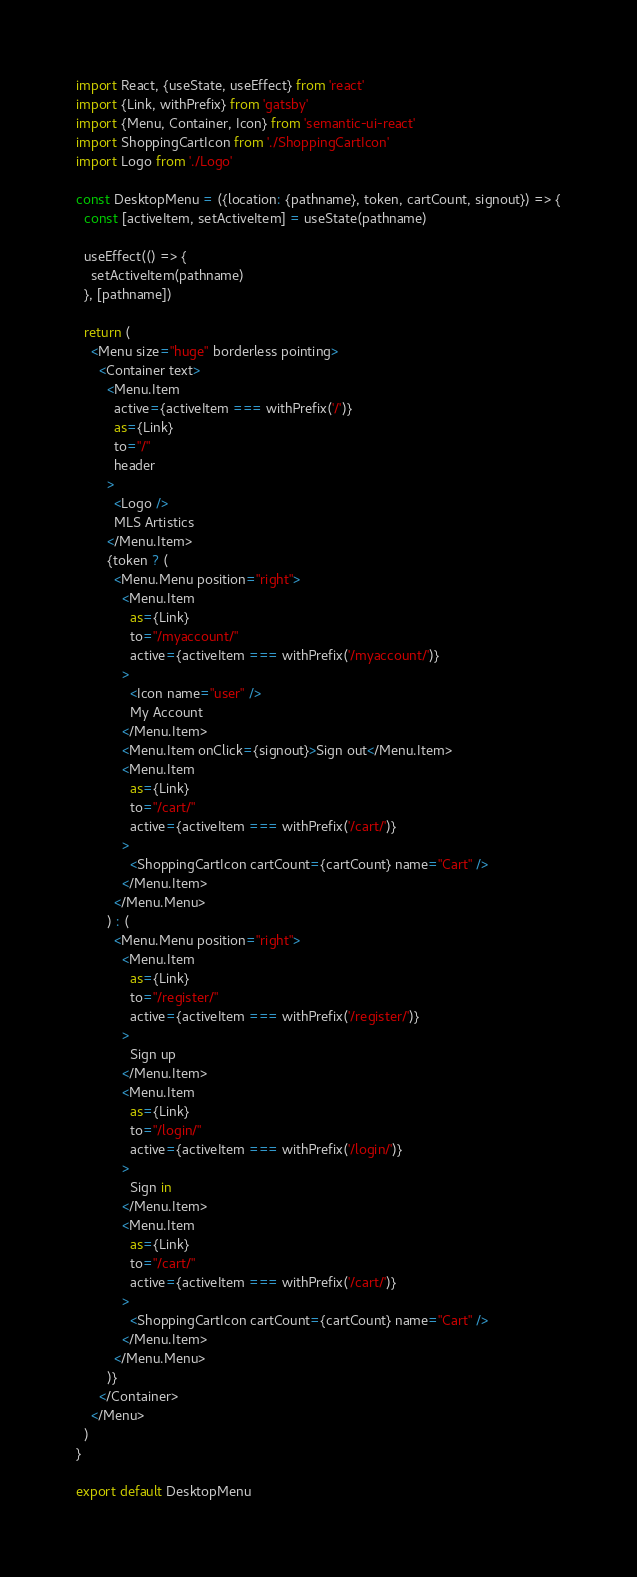<code> <loc_0><loc_0><loc_500><loc_500><_JavaScript_>import React, {useState, useEffect} from 'react'
import {Link, withPrefix} from 'gatsby'
import {Menu, Container, Icon} from 'semantic-ui-react'
import ShoppingCartIcon from './ShoppingCartIcon'
import Logo from './Logo'

const DesktopMenu = ({location: {pathname}, token, cartCount, signout}) => {
  const [activeItem, setActiveItem] = useState(pathname)

  useEffect(() => {
    setActiveItem(pathname)
  }, [pathname])

  return (
    <Menu size="huge" borderless pointing>
      <Container text>
        <Menu.Item
          active={activeItem === withPrefix('/')}
          as={Link}
          to="/"
          header
        >
          <Logo />
          MLS Artistics
        </Menu.Item>
        {token ? (
          <Menu.Menu position="right">
            <Menu.Item
              as={Link}
              to="/myaccount/"
              active={activeItem === withPrefix('/myaccount/')}
            >
              <Icon name="user" />
              My Account
            </Menu.Item>
            <Menu.Item onClick={signout}>Sign out</Menu.Item>
            <Menu.Item
              as={Link}
              to="/cart/"
              active={activeItem === withPrefix('/cart/')}
            >
              <ShoppingCartIcon cartCount={cartCount} name="Cart" />
            </Menu.Item>
          </Menu.Menu>
        ) : (
          <Menu.Menu position="right">
            <Menu.Item
              as={Link}
              to="/register/"
              active={activeItem === withPrefix('/register/')}
            >
              Sign up
            </Menu.Item>
            <Menu.Item
              as={Link}
              to="/login/"
              active={activeItem === withPrefix('/login/')}
            >
              Sign in
            </Menu.Item>
            <Menu.Item
              as={Link}
              to="/cart/"
              active={activeItem === withPrefix('/cart/')}
            >
              <ShoppingCartIcon cartCount={cartCount} name="Cart" />
            </Menu.Item>
          </Menu.Menu>
        )}
      </Container>
    </Menu>
  )
}

export default DesktopMenu
</code> 